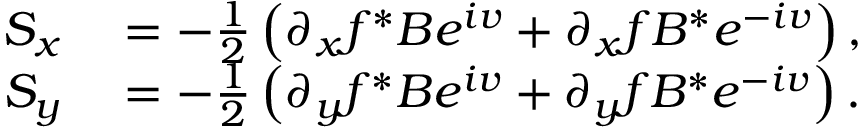<formula> <loc_0><loc_0><loc_500><loc_500>\begin{array} { r l } { S _ { x } } & = - \frac { 1 } { 2 } \left ( \partial _ { x } f ^ { * } B e ^ { i v } + \partial _ { x } f B ^ { * } e ^ { - i v } \right ) , } \\ { S _ { y } } & = - \frac { 1 } { 2 } \left ( \partial _ { y } f ^ { * } B e ^ { i v } + \partial _ { y } f B ^ { * } e ^ { - i v } \right ) . } \end{array}</formula> 